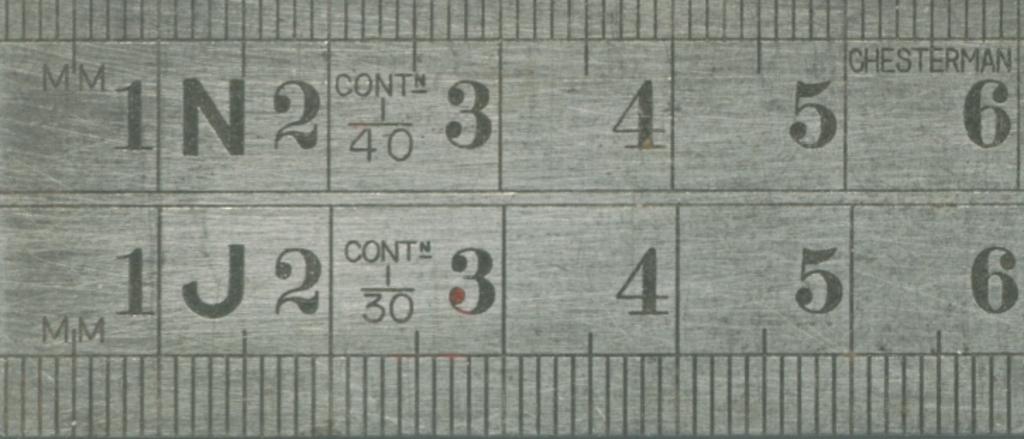Is chesterman the company that made this yard stick?
Offer a very short reply. Yes. 